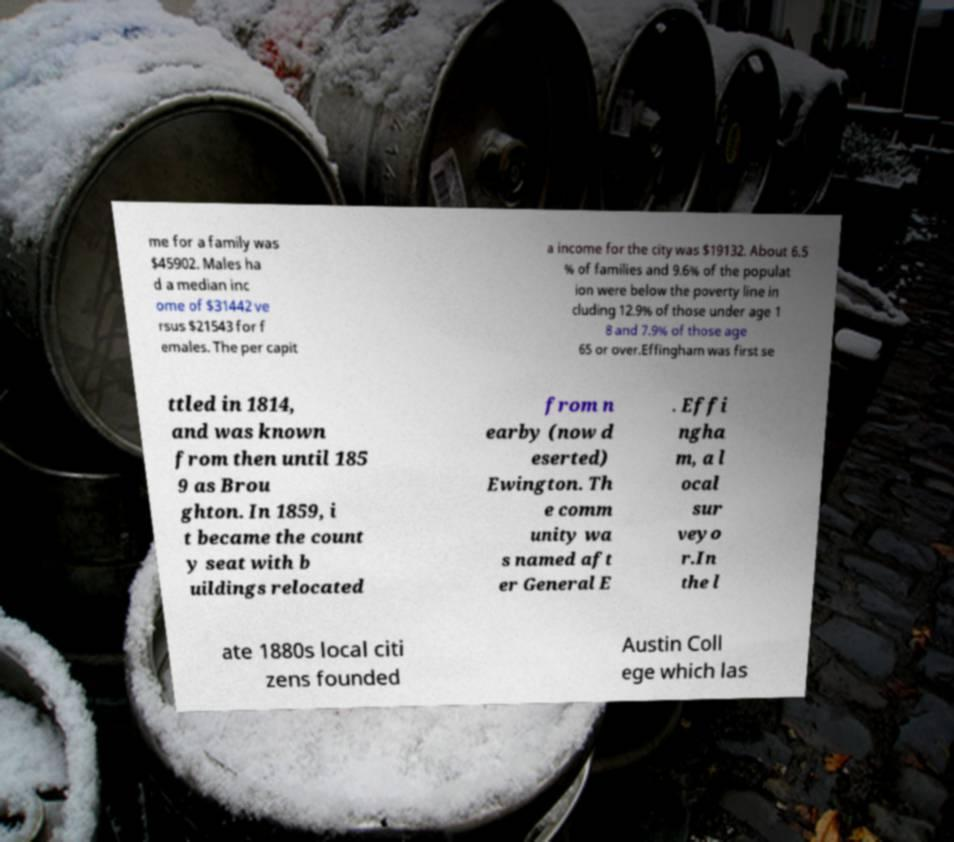Can you read and provide the text displayed in the image?This photo seems to have some interesting text. Can you extract and type it out for me? me for a family was $45902. Males ha d a median inc ome of $31442 ve rsus $21543 for f emales. The per capit a income for the city was $19132. About 6.5 % of families and 9.6% of the populat ion were below the poverty line in cluding 12.9% of those under age 1 8 and 7.9% of those age 65 or over.Effingham was first se ttled in 1814, and was known from then until 185 9 as Brou ghton. In 1859, i t became the count y seat with b uildings relocated from n earby (now d eserted) Ewington. Th e comm unity wa s named aft er General E . Effi ngha m, a l ocal sur veyo r.In the l ate 1880s local citi zens founded Austin Coll ege which las 